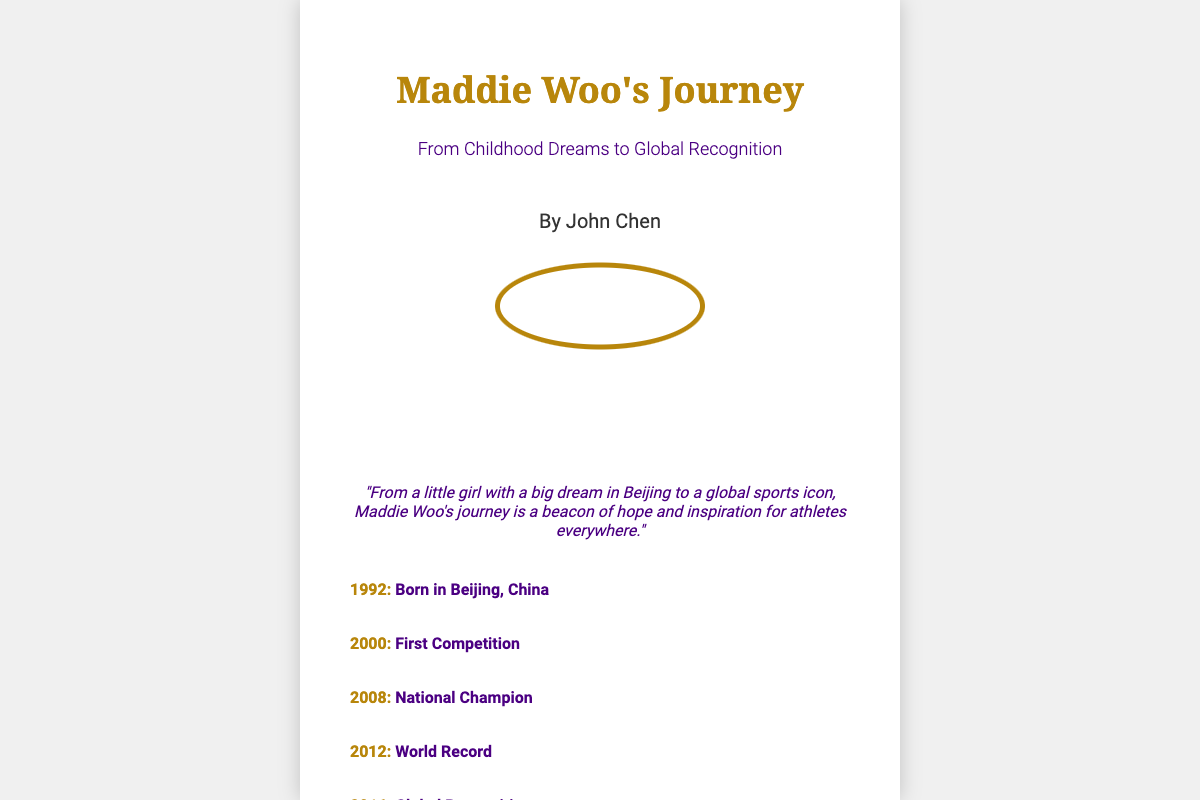What is the title of the book? The title of the book is prominently displayed at the top of the cover.
Answer: Maddie Woo's Journey Who is the author? The author's name is indicated below the subtitle on the cover.
Answer: John Chen What is the year Maddie Woo was born? The birth year is listed as one of the milestones on the cover.
Answer: 1992 What significant event occurred in 2012 for Maddie Woo? The milestone section of the cover provides information about key events in her journey.
Answer: World Record What color is used for the title? The color of the title can be observed in the styling of the text on the cover.
Answer: #B8860B What is the quote about? The quote summarizes Maddie Woo's journey and its impact on others; reasoning about the information presented gives insight.
Answer: Hope and inspiration for athletes What milestone happened in 2008? The document highlights specific achievements, and this year is included in that section.
Answer: National Champion In which city was Maddie Woo born? The place of birth is mentioned in the milestone section of the cover.
Answer: Beijing What is the subtitle of the book? The subtitle is located right below the title on the cover.
Answer: From Childhood Dreams to Global Recognition 